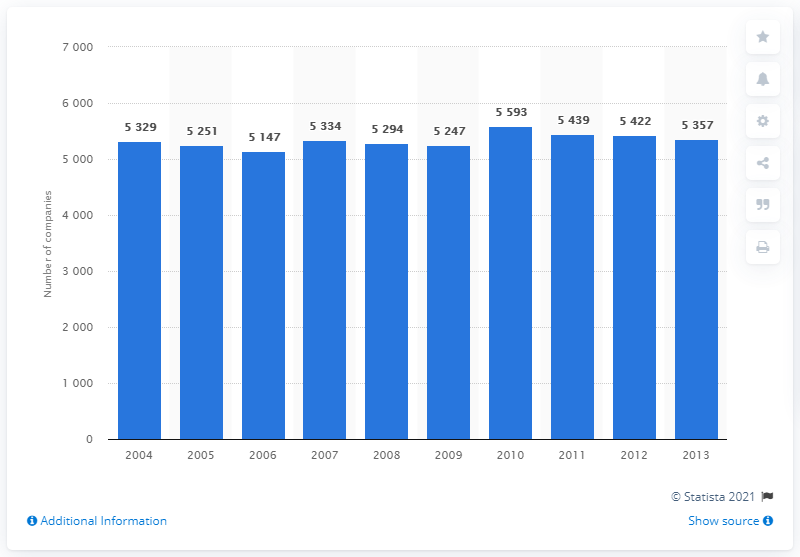What was the highest number of companies active in the insurance sector during the years shown? The highest number of active insurance companies was in the year 2009, with a total of 5,593 companies. 